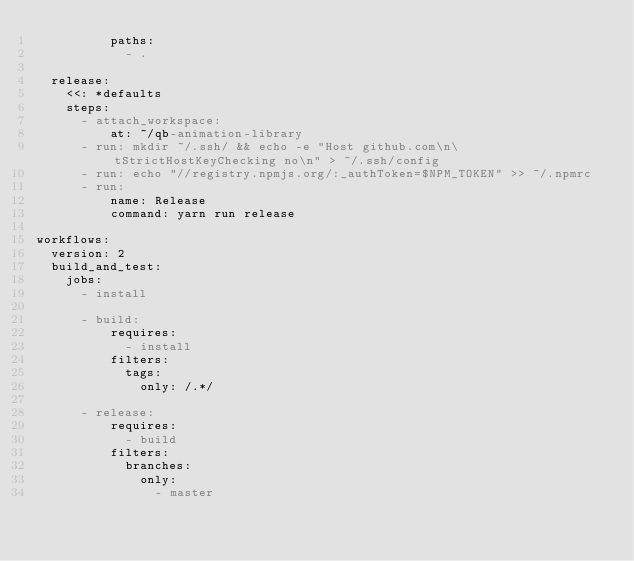Convert code to text. <code><loc_0><loc_0><loc_500><loc_500><_YAML_>          paths:
            - .

  release:
    <<: *defaults
    steps:
      - attach_workspace:
          at: ~/qb-animation-library
      - run: mkdir ~/.ssh/ && echo -e "Host github.com\n\tStrictHostKeyChecking no\n" > ~/.ssh/config
      - run: echo "//registry.npmjs.org/:_authToken=$NPM_TOKEN" >> ~/.npmrc
      - run:
          name: Release
          command: yarn run release

workflows:
  version: 2
  build_and_test:
    jobs:
      - install

      - build:
          requires:
            - install
          filters:
            tags:
              only: /.*/

      - release:
          requires:
            - build
          filters:
            branches:
              only:
                - master
</code> 